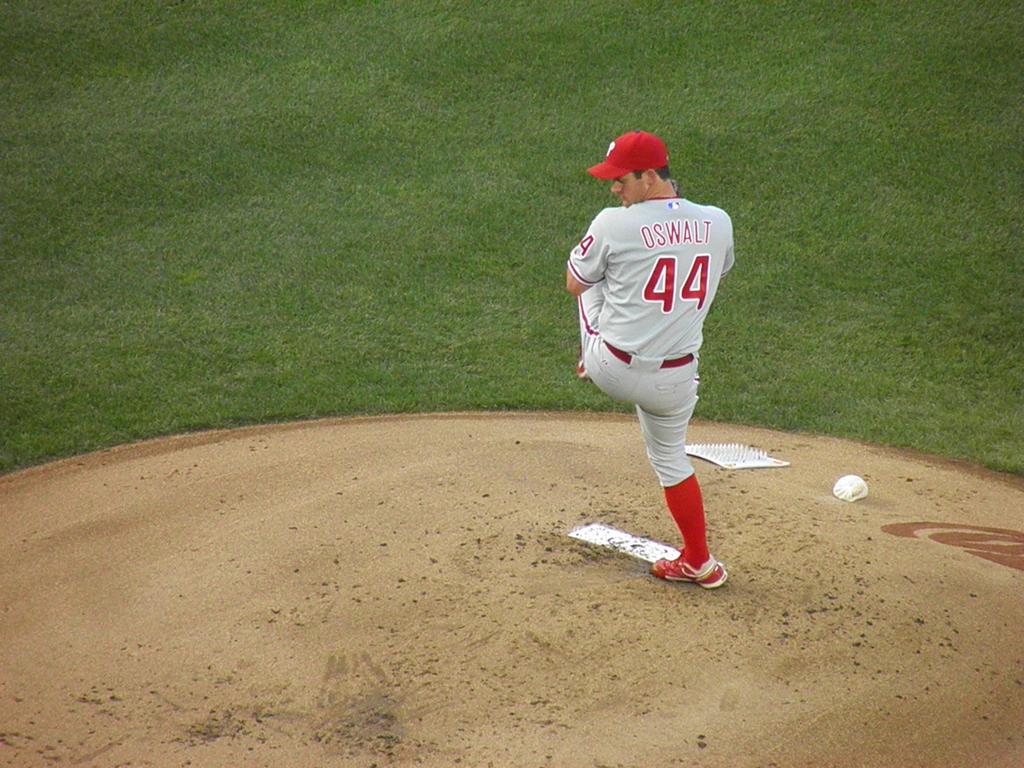What is the last name of the pitcher?
Make the answer very short. Oswalt. What is the pitcher's jersey number?
Provide a succinct answer. 44. 